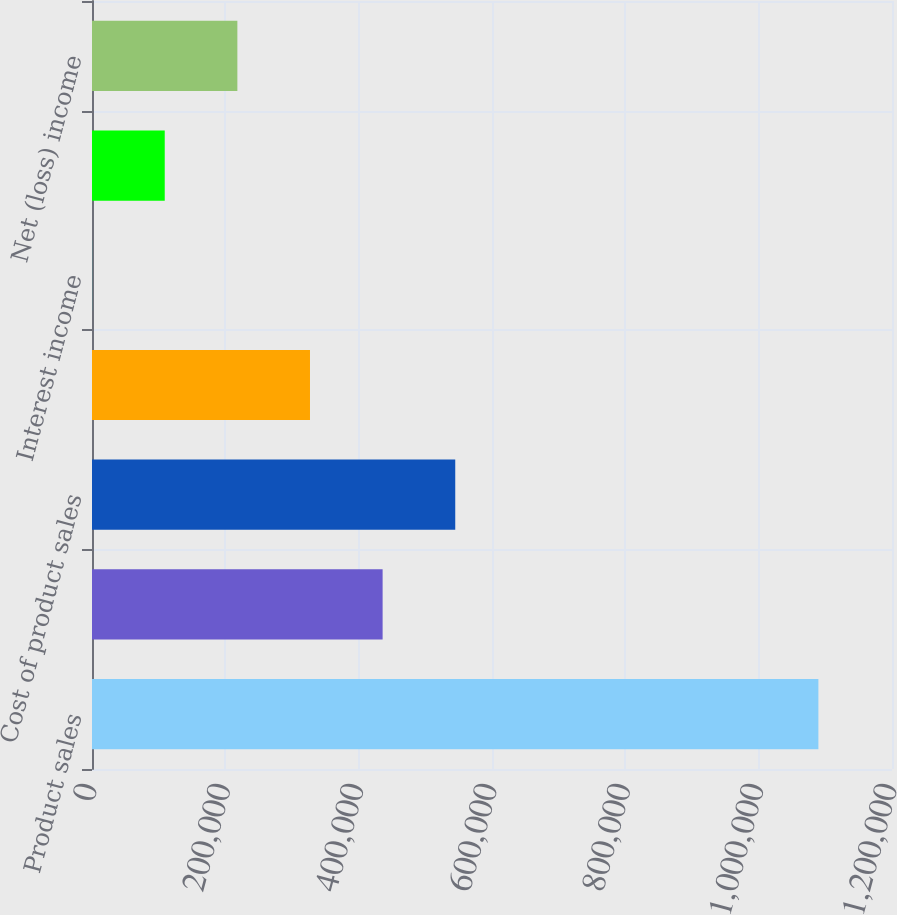<chart> <loc_0><loc_0><loc_500><loc_500><bar_chart><fcel>Product sales<fcel>Service and other revenues<fcel>Cost of product sales<fcel>Cost of service and other<fcel>Interest income<fcel>Other income net<fcel>Net (loss) income<nl><fcel>1.08958e+06<fcel>435927<fcel>544870<fcel>326985<fcel>159<fcel>109101<fcel>218043<nl></chart> 